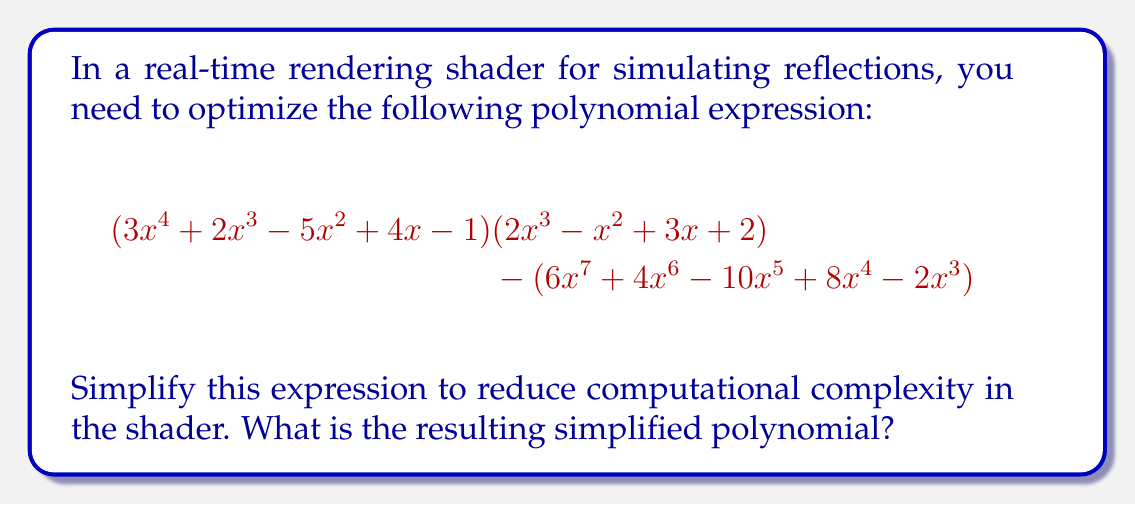Could you help me with this problem? Let's approach this step-by-step:

1) First, let's expand the product $(3x^4 + 2x^3 - 5x^2 + 4x - 1)(2x^3 - x^2 + 3x + 2)$:

   $$(3x^4)(2x^3) = 6x^7$$
   $$(3x^4)(-x^2) = -3x^6$$
   $$(3x^4)(3x) = 9x^5$$
   $$(3x^4)(2) = 6x^4$$
   
   $$(2x^3)(2x^3) = 4x^6$$
   $$(2x^3)(-x^2) = -2x^5$$
   $$(2x^3)(3x) = 6x^4$$
   $$(2x^3)(2) = 4x^3$$
   
   $$(-5x^2)(2x^3) = -10x^5$$
   $$(-5x^2)(-x^2) = 5x^4$$
   $$(-5x^2)(3x) = -15x^3$$
   $$(-5x^2)(2) = -10x^2$$
   
   $$(4x)(2x^3) = 8x^4$$
   $$(4x)(-x^2) = -4x^3$$
   $$(4x)(3x) = 12x^2$$
   $$(4x)(2) = 8x$$
   
   $$(-1)(2x^3) = -2x^3$$
   $$(-1)(-x^2) = x^2$$
   $$(-1)(3x) = -3x$$
   $$(-1)(2) = -2$$

2) Sum all these terms:

   $$6x^7 + x^6 - 3x^5 + 25x^4 - 17x^3 + 3x^2 + 5x - 2$$

3) Now, subtract $(6x^7 + 4x^6 - 10x^5 + 8x^4 - 2x^3)$ from this result:

   $$(6x^7 + x^6 - 3x^5 + 25x^4 - 17x^3 + 3x^2 + 5x - 2) - (6x^7 + 4x^6 - 10x^5 + 8x^4 - 2x^3)$$

4) Combining like terms:

   $$0x^7 + (-3x^6) + 7x^5 + 17x^4 + (-15x^3) + 3x^2 + 5x - 2$$

5) Simplify by removing the zero term and reordering:

   $$-3x^6 + 7x^5 + 17x^4 - 15x^3 + 3x^2 + 5x - 2$$

This is the simplified polynomial expression.
Answer: $$-3x^6 + 7x^5 + 17x^4 - 15x^3 + 3x^2 + 5x - 2$$ 